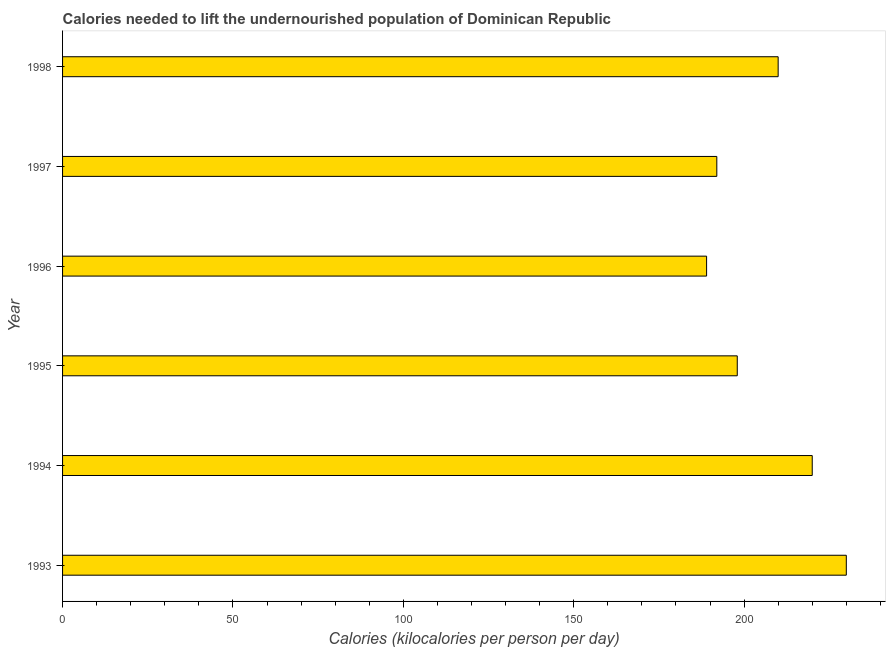Does the graph contain any zero values?
Your response must be concise. No. Does the graph contain grids?
Your answer should be compact. No. What is the title of the graph?
Offer a very short reply. Calories needed to lift the undernourished population of Dominican Republic. What is the label or title of the X-axis?
Your answer should be compact. Calories (kilocalories per person per day). What is the label or title of the Y-axis?
Give a very brief answer. Year. What is the depth of food deficit in 1996?
Ensure brevity in your answer.  189. Across all years, what is the maximum depth of food deficit?
Provide a succinct answer. 230. Across all years, what is the minimum depth of food deficit?
Ensure brevity in your answer.  189. In which year was the depth of food deficit maximum?
Keep it short and to the point. 1993. What is the sum of the depth of food deficit?
Provide a short and direct response. 1239. What is the average depth of food deficit per year?
Your answer should be very brief. 206. What is the median depth of food deficit?
Your answer should be compact. 204. What is the ratio of the depth of food deficit in 1994 to that in 1995?
Your answer should be compact. 1.11. Is the depth of food deficit in 1993 less than that in 1997?
Give a very brief answer. No. What is the difference between the highest and the second highest depth of food deficit?
Offer a terse response. 10. Is the sum of the depth of food deficit in 1993 and 1994 greater than the maximum depth of food deficit across all years?
Ensure brevity in your answer.  Yes. What is the difference between the highest and the lowest depth of food deficit?
Keep it short and to the point. 41. In how many years, is the depth of food deficit greater than the average depth of food deficit taken over all years?
Provide a short and direct response. 3. How many bars are there?
Offer a very short reply. 6. What is the Calories (kilocalories per person per day) in 1993?
Ensure brevity in your answer.  230. What is the Calories (kilocalories per person per day) in 1994?
Your answer should be compact. 220. What is the Calories (kilocalories per person per day) in 1995?
Provide a succinct answer. 198. What is the Calories (kilocalories per person per day) of 1996?
Your answer should be compact. 189. What is the Calories (kilocalories per person per day) of 1997?
Offer a terse response. 192. What is the Calories (kilocalories per person per day) of 1998?
Offer a terse response. 210. What is the difference between the Calories (kilocalories per person per day) in 1993 and 1995?
Give a very brief answer. 32. What is the difference between the Calories (kilocalories per person per day) in 1993 and 1997?
Your answer should be compact. 38. What is the difference between the Calories (kilocalories per person per day) in 1994 and 1995?
Provide a succinct answer. 22. What is the difference between the Calories (kilocalories per person per day) in 1994 and 1997?
Ensure brevity in your answer.  28. What is the difference between the Calories (kilocalories per person per day) in 1996 and 1998?
Your response must be concise. -21. What is the ratio of the Calories (kilocalories per person per day) in 1993 to that in 1994?
Offer a very short reply. 1.04. What is the ratio of the Calories (kilocalories per person per day) in 1993 to that in 1995?
Make the answer very short. 1.16. What is the ratio of the Calories (kilocalories per person per day) in 1993 to that in 1996?
Give a very brief answer. 1.22. What is the ratio of the Calories (kilocalories per person per day) in 1993 to that in 1997?
Your answer should be compact. 1.2. What is the ratio of the Calories (kilocalories per person per day) in 1993 to that in 1998?
Provide a short and direct response. 1.09. What is the ratio of the Calories (kilocalories per person per day) in 1994 to that in 1995?
Offer a very short reply. 1.11. What is the ratio of the Calories (kilocalories per person per day) in 1994 to that in 1996?
Offer a terse response. 1.16. What is the ratio of the Calories (kilocalories per person per day) in 1994 to that in 1997?
Offer a terse response. 1.15. What is the ratio of the Calories (kilocalories per person per day) in 1994 to that in 1998?
Your response must be concise. 1.05. What is the ratio of the Calories (kilocalories per person per day) in 1995 to that in 1996?
Make the answer very short. 1.05. What is the ratio of the Calories (kilocalories per person per day) in 1995 to that in 1997?
Your response must be concise. 1.03. What is the ratio of the Calories (kilocalories per person per day) in 1995 to that in 1998?
Offer a very short reply. 0.94. What is the ratio of the Calories (kilocalories per person per day) in 1997 to that in 1998?
Offer a terse response. 0.91. 